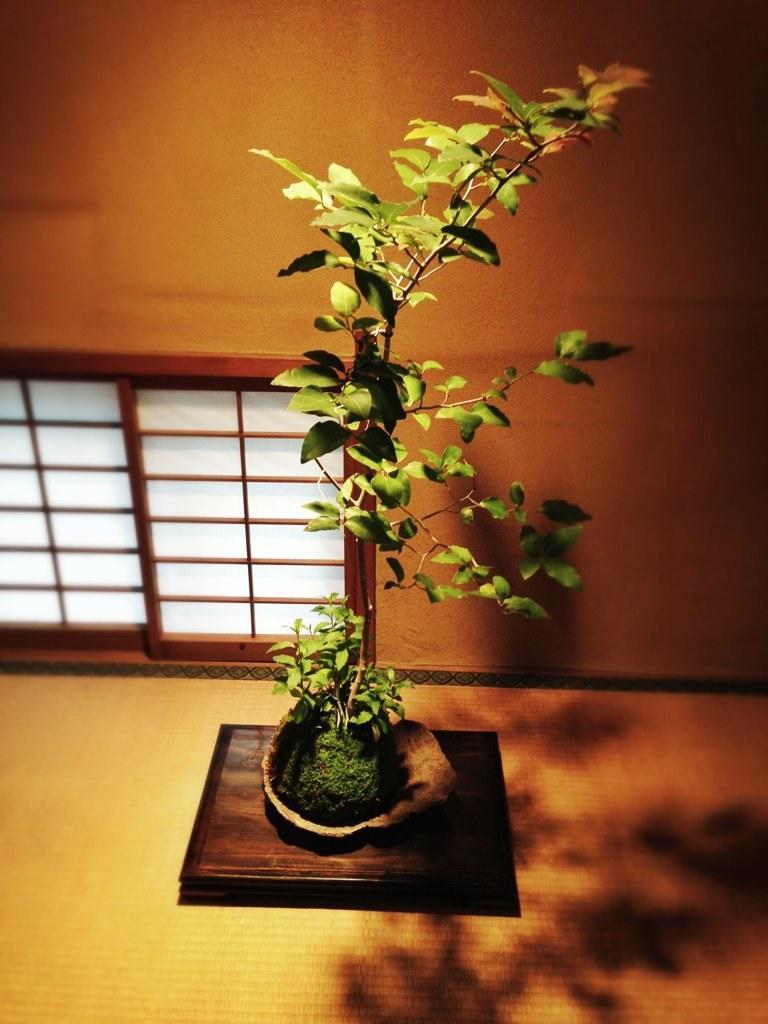Could you give a brief overview of what you see in this image? In this image I can see a plant in the front and on the ground I can see a shadow. On the left side of this image I can see a window. 